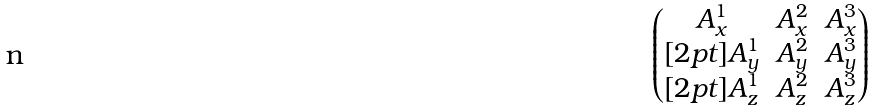Convert formula to latex. <formula><loc_0><loc_0><loc_500><loc_500>\begin{pmatrix} A _ { x } ^ { 1 } & A _ { x } ^ { 2 } & A _ { x } ^ { 3 } \\ [ 2 p t ] A _ { y } ^ { 1 } & A _ { y } ^ { 2 } & A _ { y } ^ { 3 } \\ [ 2 p t ] A _ { z } ^ { 1 } & A _ { z } ^ { 2 } & A _ { z } ^ { 3 } \end{pmatrix}</formula> 